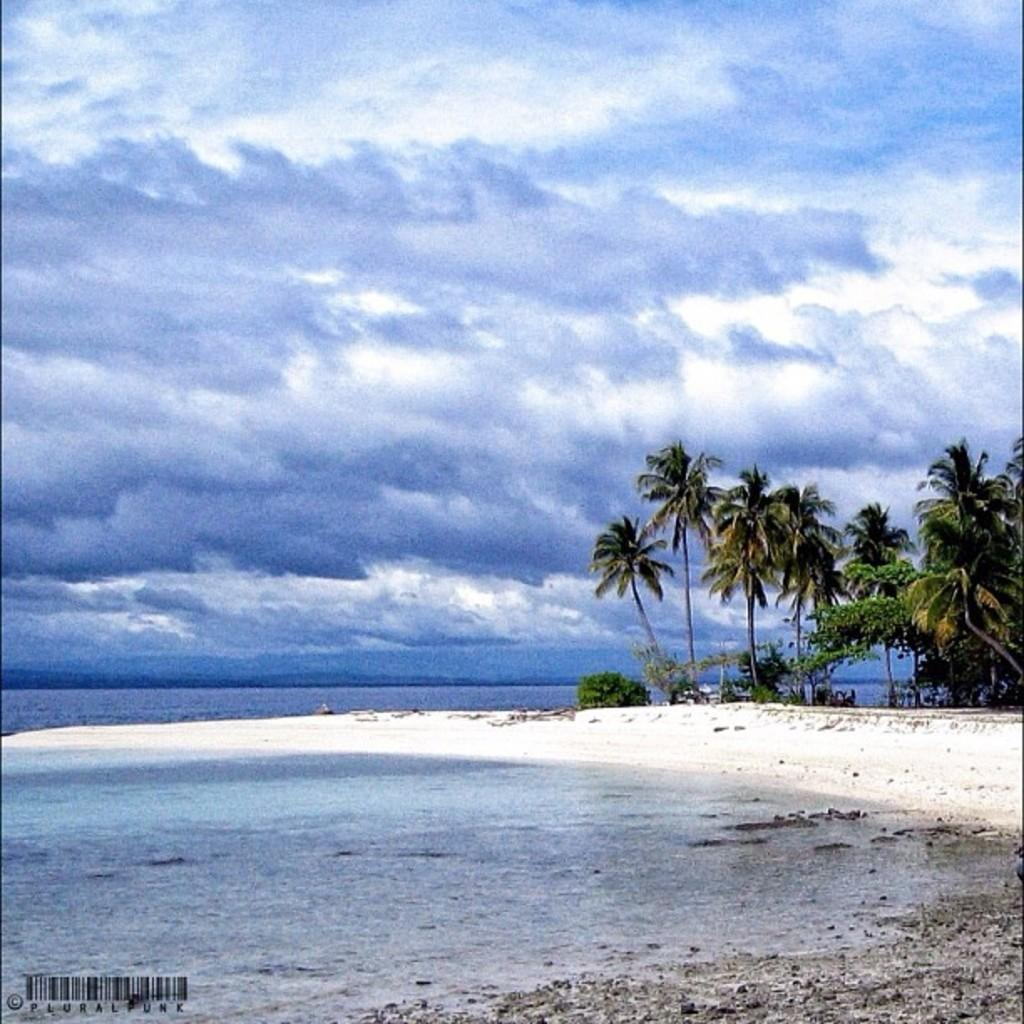What type of location is shown in the image? The image depicts a beach. What can be seen on the left side of the image? There is water on the left side of the image. What type of vegetation is on the right side of the image? There are trees on the right side of the image. What is visible at the top of the image? The sky is visible at the top of the image. What can be observed in the sky? Clouds are present in the sky. What type of mint can be seen growing near the water in the image? There is no mint present in the image; it depicts a beach with water, trees, and a sky with clouds. 